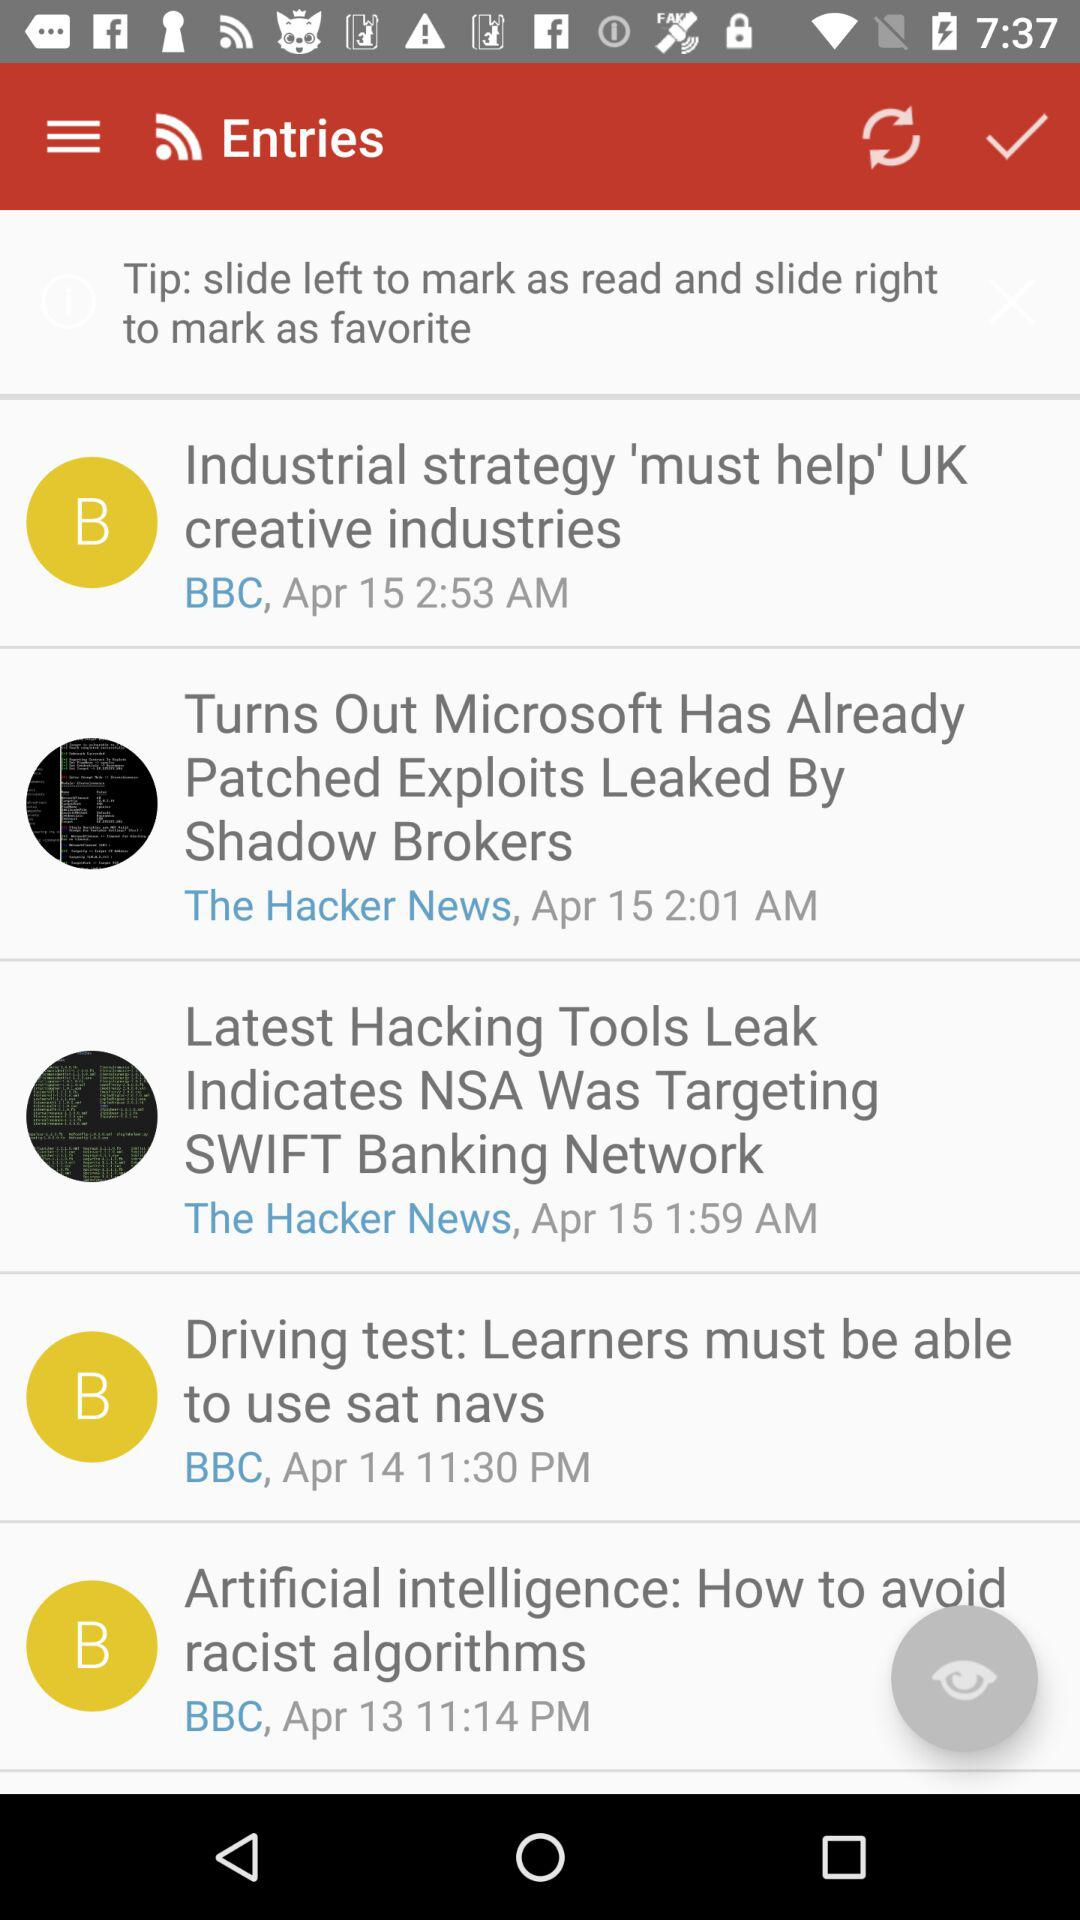On what date was "Artificial intelligence: How to avoid racist algorithms" posted? "Artificial intelligence: How to avoid racist algorithms" was posted on April 13. 